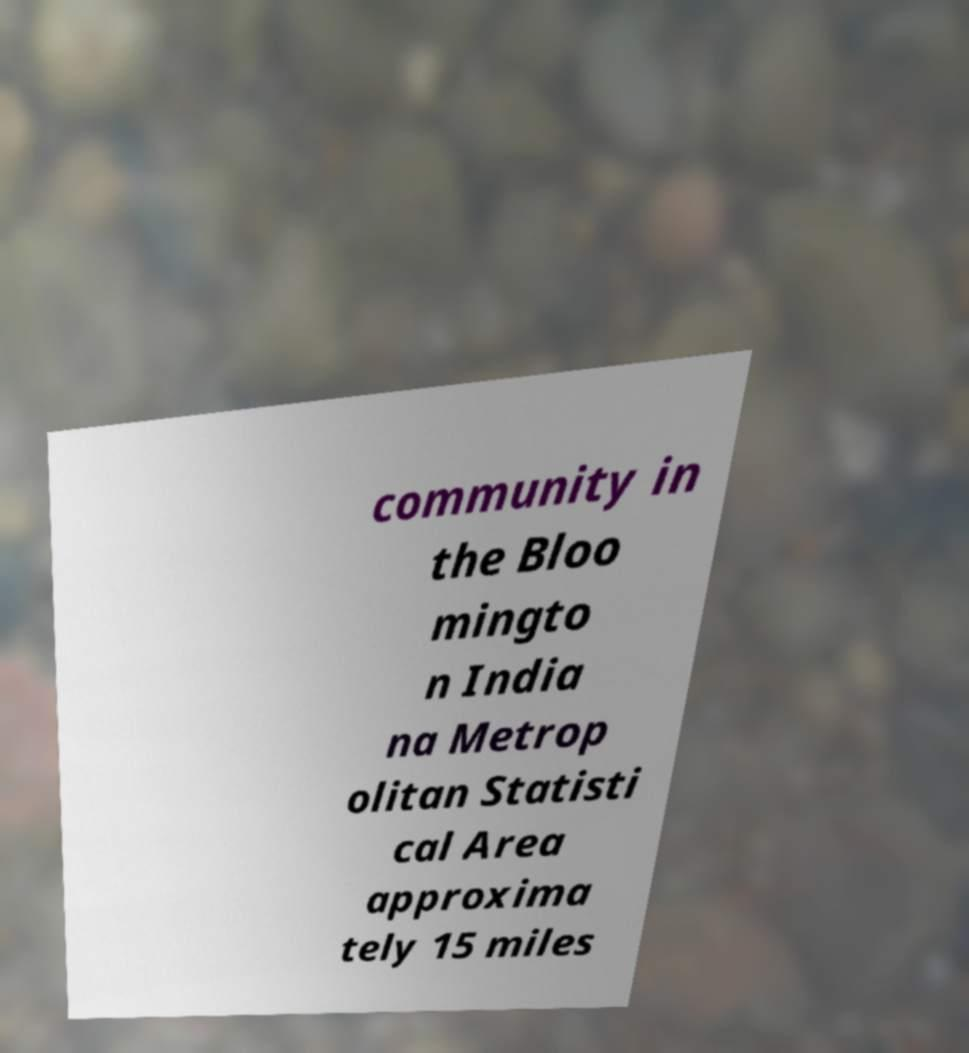I need the written content from this picture converted into text. Can you do that? community in the Bloo mingto n India na Metrop olitan Statisti cal Area approxima tely 15 miles 